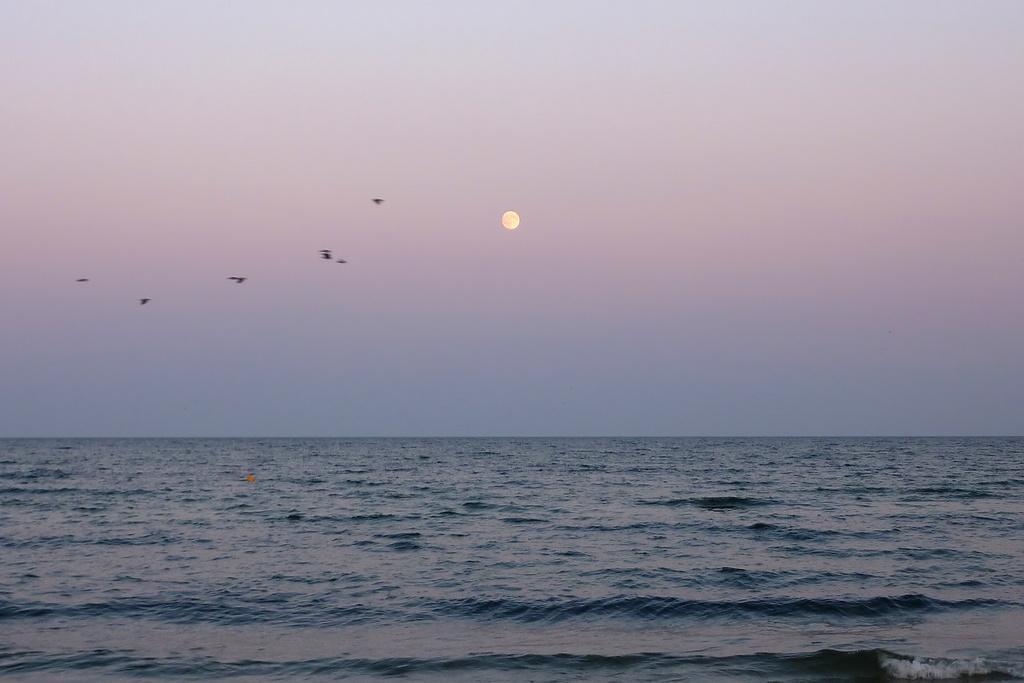In one or two sentences, can you explain what this image depicts? There are birds, this is water and a sky. 